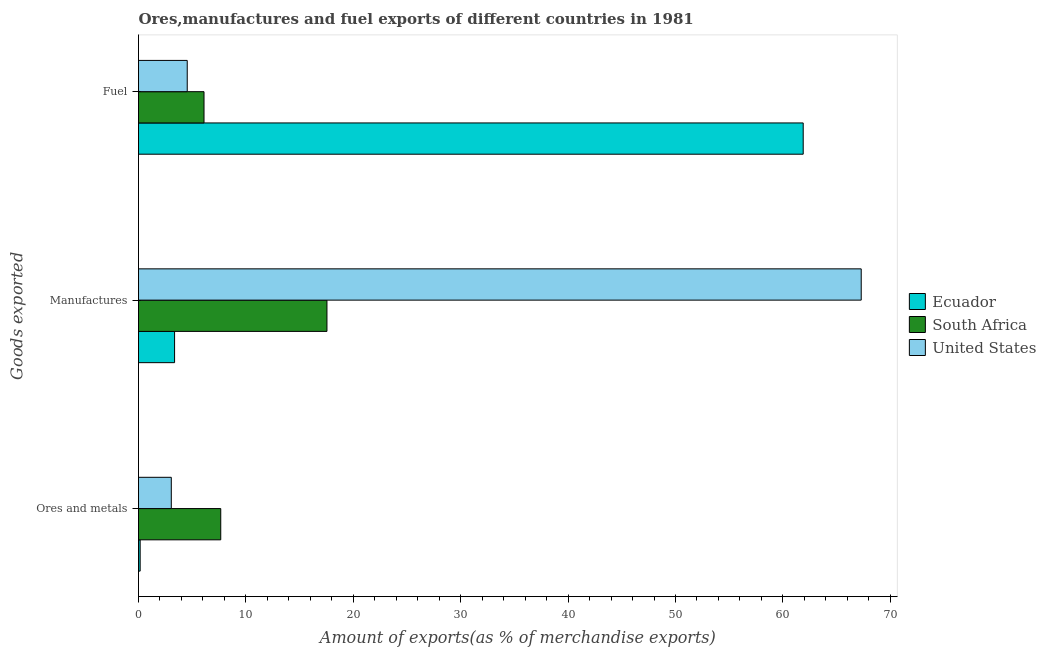How many different coloured bars are there?
Offer a terse response. 3. How many groups of bars are there?
Your answer should be very brief. 3. Are the number of bars per tick equal to the number of legend labels?
Offer a very short reply. Yes. How many bars are there on the 1st tick from the top?
Make the answer very short. 3. What is the label of the 1st group of bars from the top?
Provide a succinct answer. Fuel. What is the percentage of manufactures exports in Ecuador?
Ensure brevity in your answer.  3.36. Across all countries, what is the maximum percentage of ores and metals exports?
Your answer should be very brief. 7.66. Across all countries, what is the minimum percentage of fuel exports?
Offer a terse response. 4.54. In which country was the percentage of fuel exports maximum?
Keep it short and to the point. Ecuador. In which country was the percentage of manufactures exports minimum?
Provide a succinct answer. Ecuador. What is the total percentage of fuel exports in the graph?
Provide a succinct answer. 72.53. What is the difference between the percentage of fuel exports in South Africa and that in United States?
Offer a very short reply. 1.56. What is the difference between the percentage of manufactures exports in United States and the percentage of ores and metals exports in South Africa?
Your response must be concise. 59.63. What is the average percentage of ores and metals exports per country?
Ensure brevity in your answer.  3.62. What is the difference between the percentage of manufactures exports and percentage of fuel exports in United States?
Keep it short and to the point. 62.75. In how many countries, is the percentage of fuel exports greater than 36 %?
Your answer should be compact. 1. What is the ratio of the percentage of fuel exports in South Africa to that in United States?
Give a very brief answer. 1.34. Is the percentage of ores and metals exports in Ecuador less than that in United States?
Offer a terse response. Yes. What is the difference between the highest and the second highest percentage of fuel exports?
Your answer should be very brief. 55.79. What is the difference between the highest and the lowest percentage of manufactures exports?
Ensure brevity in your answer.  63.93. In how many countries, is the percentage of ores and metals exports greater than the average percentage of ores and metals exports taken over all countries?
Offer a very short reply. 1. Is the sum of the percentage of ores and metals exports in United States and South Africa greater than the maximum percentage of fuel exports across all countries?
Your answer should be very brief. No. What does the 2nd bar from the top in Manufactures represents?
Give a very brief answer. South Africa. What does the 2nd bar from the bottom in Manufactures represents?
Ensure brevity in your answer.  South Africa. Is it the case that in every country, the sum of the percentage of ores and metals exports and percentage of manufactures exports is greater than the percentage of fuel exports?
Offer a terse response. No. How many bars are there?
Provide a short and direct response. 9. Are all the bars in the graph horizontal?
Your answer should be compact. Yes. Are the values on the major ticks of X-axis written in scientific E-notation?
Ensure brevity in your answer.  No. Where does the legend appear in the graph?
Offer a very short reply. Center right. How many legend labels are there?
Your answer should be compact. 3. What is the title of the graph?
Offer a terse response. Ores,manufactures and fuel exports of different countries in 1981. Does "Australia" appear as one of the legend labels in the graph?
Your response must be concise. No. What is the label or title of the X-axis?
Ensure brevity in your answer.  Amount of exports(as % of merchandise exports). What is the label or title of the Y-axis?
Give a very brief answer. Goods exported. What is the Amount of exports(as % of merchandise exports) in Ecuador in Ores and metals?
Offer a terse response. 0.15. What is the Amount of exports(as % of merchandise exports) of South Africa in Ores and metals?
Your answer should be compact. 7.66. What is the Amount of exports(as % of merchandise exports) of United States in Ores and metals?
Ensure brevity in your answer.  3.05. What is the Amount of exports(as % of merchandise exports) in Ecuador in Manufactures?
Offer a very short reply. 3.36. What is the Amount of exports(as % of merchandise exports) in South Africa in Manufactures?
Make the answer very short. 17.55. What is the Amount of exports(as % of merchandise exports) of United States in Manufactures?
Your answer should be compact. 67.29. What is the Amount of exports(as % of merchandise exports) of Ecuador in Fuel?
Offer a very short reply. 61.89. What is the Amount of exports(as % of merchandise exports) in South Africa in Fuel?
Make the answer very short. 6.1. What is the Amount of exports(as % of merchandise exports) in United States in Fuel?
Give a very brief answer. 4.54. Across all Goods exported, what is the maximum Amount of exports(as % of merchandise exports) of Ecuador?
Offer a terse response. 61.89. Across all Goods exported, what is the maximum Amount of exports(as % of merchandise exports) of South Africa?
Give a very brief answer. 17.55. Across all Goods exported, what is the maximum Amount of exports(as % of merchandise exports) of United States?
Ensure brevity in your answer.  67.29. Across all Goods exported, what is the minimum Amount of exports(as % of merchandise exports) in Ecuador?
Your response must be concise. 0.15. Across all Goods exported, what is the minimum Amount of exports(as % of merchandise exports) in South Africa?
Offer a terse response. 6.1. Across all Goods exported, what is the minimum Amount of exports(as % of merchandise exports) in United States?
Provide a succinct answer. 3.05. What is the total Amount of exports(as % of merchandise exports) of Ecuador in the graph?
Offer a terse response. 65.4. What is the total Amount of exports(as % of merchandise exports) of South Africa in the graph?
Make the answer very short. 31.3. What is the total Amount of exports(as % of merchandise exports) in United States in the graph?
Your answer should be compact. 74.88. What is the difference between the Amount of exports(as % of merchandise exports) in Ecuador in Ores and metals and that in Manufactures?
Offer a terse response. -3.2. What is the difference between the Amount of exports(as % of merchandise exports) in South Africa in Ores and metals and that in Manufactures?
Offer a terse response. -9.89. What is the difference between the Amount of exports(as % of merchandise exports) of United States in Ores and metals and that in Manufactures?
Your answer should be compact. -64.24. What is the difference between the Amount of exports(as % of merchandise exports) of Ecuador in Ores and metals and that in Fuel?
Offer a terse response. -61.74. What is the difference between the Amount of exports(as % of merchandise exports) of South Africa in Ores and metals and that in Fuel?
Make the answer very short. 1.56. What is the difference between the Amount of exports(as % of merchandise exports) in United States in Ores and metals and that in Fuel?
Provide a succinct answer. -1.49. What is the difference between the Amount of exports(as % of merchandise exports) of Ecuador in Manufactures and that in Fuel?
Give a very brief answer. -58.53. What is the difference between the Amount of exports(as % of merchandise exports) of South Africa in Manufactures and that in Fuel?
Give a very brief answer. 11.45. What is the difference between the Amount of exports(as % of merchandise exports) in United States in Manufactures and that in Fuel?
Make the answer very short. 62.75. What is the difference between the Amount of exports(as % of merchandise exports) in Ecuador in Ores and metals and the Amount of exports(as % of merchandise exports) in South Africa in Manufactures?
Offer a terse response. -17.39. What is the difference between the Amount of exports(as % of merchandise exports) in Ecuador in Ores and metals and the Amount of exports(as % of merchandise exports) in United States in Manufactures?
Offer a very short reply. -67.14. What is the difference between the Amount of exports(as % of merchandise exports) in South Africa in Ores and metals and the Amount of exports(as % of merchandise exports) in United States in Manufactures?
Make the answer very short. -59.63. What is the difference between the Amount of exports(as % of merchandise exports) in Ecuador in Ores and metals and the Amount of exports(as % of merchandise exports) in South Africa in Fuel?
Your answer should be compact. -5.95. What is the difference between the Amount of exports(as % of merchandise exports) in Ecuador in Ores and metals and the Amount of exports(as % of merchandise exports) in United States in Fuel?
Offer a very short reply. -4.38. What is the difference between the Amount of exports(as % of merchandise exports) in South Africa in Ores and metals and the Amount of exports(as % of merchandise exports) in United States in Fuel?
Make the answer very short. 3.12. What is the difference between the Amount of exports(as % of merchandise exports) of Ecuador in Manufactures and the Amount of exports(as % of merchandise exports) of South Africa in Fuel?
Provide a succinct answer. -2.74. What is the difference between the Amount of exports(as % of merchandise exports) in Ecuador in Manufactures and the Amount of exports(as % of merchandise exports) in United States in Fuel?
Offer a very short reply. -1.18. What is the difference between the Amount of exports(as % of merchandise exports) of South Africa in Manufactures and the Amount of exports(as % of merchandise exports) of United States in Fuel?
Offer a terse response. 13.01. What is the average Amount of exports(as % of merchandise exports) in Ecuador per Goods exported?
Make the answer very short. 21.8. What is the average Amount of exports(as % of merchandise exports) of South Africa per Goods exported?
Your response must be concise. 10.43. What is the average Amount of exports(as % of merchandise exports) of United States per Goods exported?
Keep it short and to the point. 24.96. What is the difference between the Amount of exports(as % of merchandise exports) in Ecuador and Amount of exports(as % of merchandise exports) in South Africa in Ores and metals?
Offer a very short reply. -7.5. What is the difference between the Amount of exports(as % of merchandise exports) in Ecuador and Amount of exports(as % of merchandise exports) in United States in Ores and metals?
Your answer should be compact. -2.9. What is the difference between the Amount of exports(as % of merchandise exports) in South Africa and Amount of exports(as % of merchandise exports) in United States in Ores and metals?
Make the answer very short. 4.61. What is the difference between the Amount of exports(as % of merchandise exports) of Ecuador and Amount of exports(as % of merchandise exports) of South Africa in Manufactures?
Give a very brief answer. -14.19. What is the difference between the Amount of exports(as % of merchandise exports) of Ecuador and Amount of exports(as % of merchandise exports) of United States in Manufactures?
Offer a terse response. -63.93. What is the difference between the Amount of exports(as % of merchandise exports) in South Africa and Amount of exports(as % of merchandise exports) in United States in Manufactures?
Your answer should be compact. -49.74. What is the difference between the Amount of exports(as % of merchandise exports) of Ecuador and Amount of exports(as % of merchandise exports) of South Africa in Fuel?
Your answer should be compact. 55.79. What is the difference between the Amount of exports(as % of merchandise exports) of Ecuador and Amount of exports(as % of merchandise exports) of United States in Fuel?
Your answer should be very brief. 57.35. What is the difference between the Amount of exports(as % of merchandise exports) of South Africa and Amount of exports(as % of merchandise exports) of United States in Fuel?
Make the answer very short. 1.56. What is the ratio of the Amount of exports(as % of merchandise exports) in Ecuador in Ores and metals to that in Manufactures?
Offer a terse response. 0.05. What is the ratio of the Amount of exports(as % of merchandise exports) in South Africa in Ores and metals to that in Manufactures?
Keep it short and to the point. 0.44. What is the ratio of the Amount of exports(as % of merchandise exports) of United States in Ores and metals to that in Manufactures?
Make the answer very short. 0.05. What is the ratio of the Amount of exports(as % of merchandise exports) in Ecuador in Ores and metals to that in Fuel?
Your answer should be very brief. 0. What is the ratio of the Amount of exports(as % of merchandise exports) of South Africa in Ores and metals to that in Fuel?
Keep it short and to the point. 1.26. What is the ratio of the Amount of exports(as % of merchandise exports) in United States in Ores and metals to that in Fuel?
Your answer should be very brief. 0.67. What is the ratio of the Amount of exports(as % of merchandise exports) in Ecuador in Manufactures to that in Fuel?
Your answer should be compact. 0.05. What is the ratio of the Amount of exports(as % of merchandise exports) in South Africa in Manufactures to that in Fuel?
Provide a short and direct response. 2.88. What is the ratio of the Amount of exports(as % of merchandise exports) in United States in Manufactures to that in Fuel?
Keep it short and to the point. 14.83. What is the difference between the highest and the second highest Amount of exports(as % of merchandise exports) in Ecuador?
Your answer should be very brief. 58.53. What is the difference between the highest and the second highest Amount of exports(as % of merchandise exports) of South Africa?
Keep it short and to the point. 9.89. What is the difference between the highest and the second highest Amount of exports(as % of merchandise exports) of United States?
Your response must be concise. 62.75. What is the difference between the highest and the lowest Amount of exports(as % of merchandise exports) in Ecuador?
Ensure brevity in your answer.  61.74. What is the difference between the highest and the lowest Amount of exports(as % of merchandise exports) of South Africa?
Your response must be concise. 11.45. What is the difference between the highest and the lowest Amount of exports(as % of merchandise exports) in United States?
Ensure brevity in your answer.  64.24. 